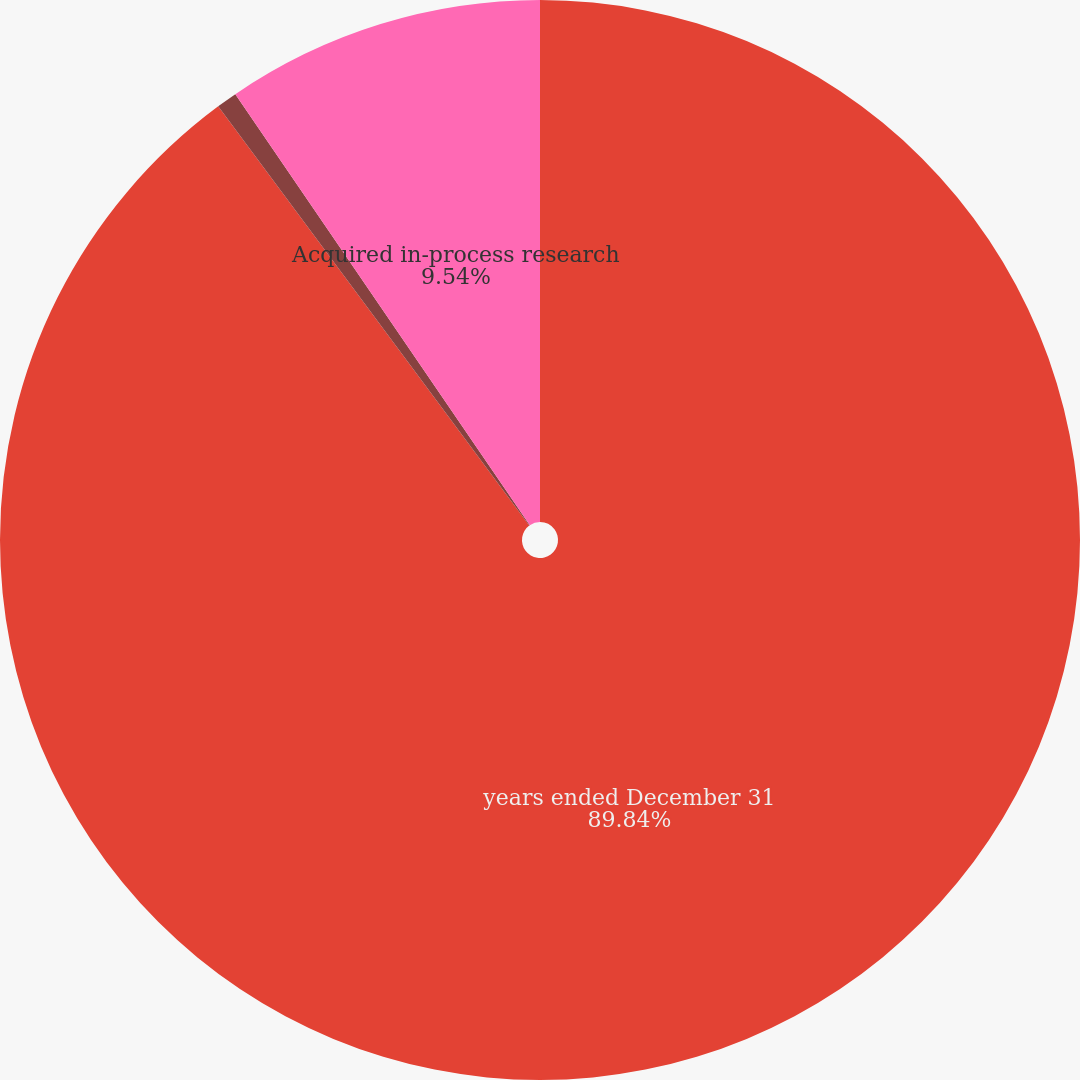Convert chart to OTSL. <chart><loc_0><loc_0><loc_500><loc_500><pie_chart><fcel>years ended December 31<fcel>Research and development<fcel>Acquired in-process research<nl><fcel>89.83%<fcel>0.62%<fcel>9.54%<nl></chart> 